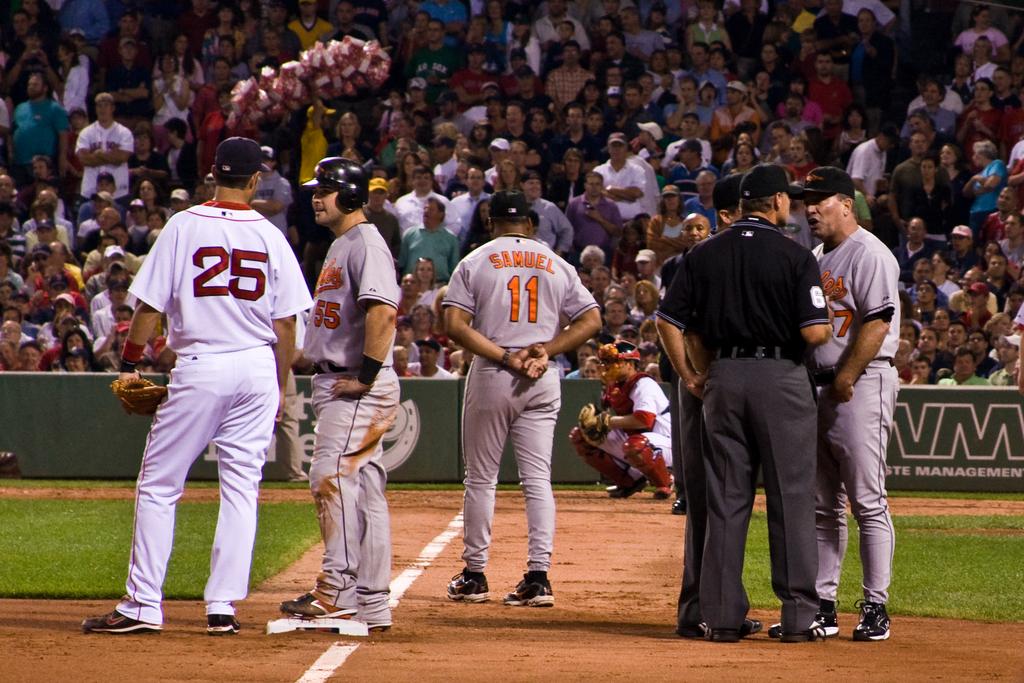What number on first baseman?
Give a very brief answer. 25. 